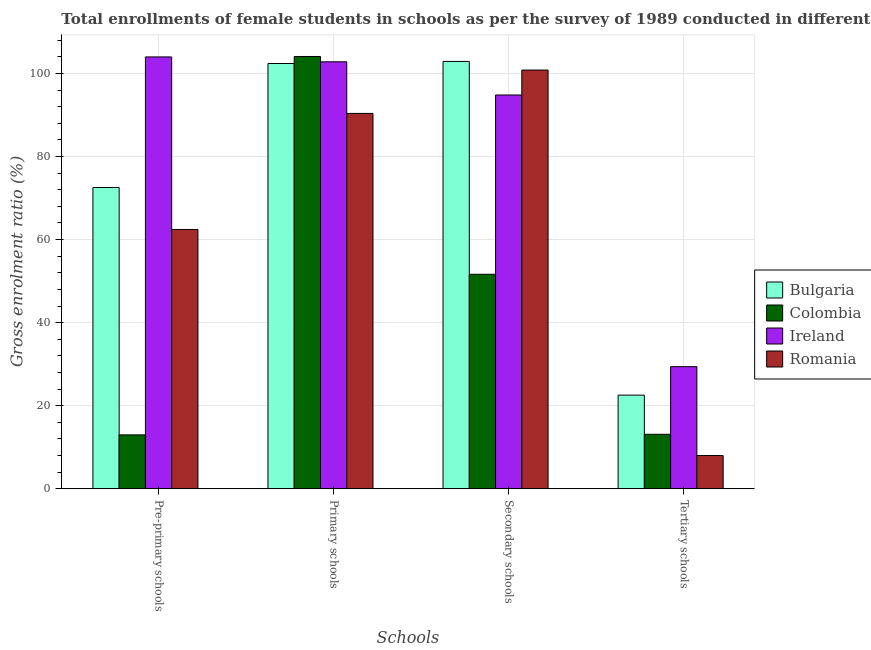How many different coloured bars are there?
Keep it short and to the point. 4. How many groups of bars are there?
Offer a very short reply. 4. Are the number of bars per tick equal to the number of legend labels?
Keep it short and to the point. Yes. Are the number of bars on each tick of the X-axis equal?
Ensure brevity in your answer.  Yes. How many bars are there on the 4th tick from the right?
Give a very brief answer. 4. What is the label of the 3rd group of bars from the left?
Make the answer very short. Secondary schools. What is the gross enrolment ratio(female) in secondary schools in Bulgaria?
Your answer should be very brief. 102.91. Across all countries, what is the maximum gross enrolment ratio(female) in pre-primary schools?
Your response must be concise. 103.99. Across all countries, what is the minimum gross enrolment ratio(female) in pre-primary schools?
Make the answer very short. 12.96. In which country was the gross enrolment ratio(female) in secondary schools maximum?
Give a very brief answer. Bulgaria. In which country was the gross enrolment ratio(female) in pre-primary schools minimum?
Your answer should be compact. Colombia. What is the total gross enrolment ratio(female) in tertiary schools in the graph?
Provide a short and direct response. 73.01. What is the difference between the gross enrolment ratio(female) in secondary schools in Bulgaria and that in Ireland?
Your response must be concise. 8.08. What is the difference between the gross enrolment ratio(female) in pre-primary schools in Ireland and the gross enrolment ratio(female) in tertiary schools in Romania?
Provide a short and direct response. 96.01. What is the average gross enrolment ratio(female) in pre-primary schools per country?
Keep it short and to the point. 62.98. What is the difference between the gross enrolment ratio(female) in primary schools and gross enrolment ratio(female) in tertiary schools in Romania?
Make the answer very short. 82.4. In how many countries, is the gross enrolment ratio(female) in pre-primary schools greater than 56 %?
Give a very brief answer. 3. What is the ratio of the gross enrolment ratio(female) in primary schools in Romania to that in Ireland?
Give a very brief answer. 0.88. What is the difference between the highest and the second highest gross enrolment ratio(female) in primary schools?
Your response must be concise. 1.28. What is the difference between the highest and the lowest gross enrolment ratio(female) in primary schools?
Keep it short and to the point. 13.71. In how many countries, is the gross enrolment ratio(female) in secondary schools greater than the average gross enrolment ratio(female) in secondary schools taken over all countries?
Your answer should be very brief. 3. Is the sum of the gross enrolment ratio(female) in primary schools in Ireland and Bulgaria greater than the maximum gross enrolment ratio(female) in pre-primary schools across all countries?
Your response must be concise. Yes. Is it the case that in every country, the sum of the gross enrolment ratio(female) in tertiary schools and gross enrolment ratio(female) in pre-primary schools is greater than the sum of gross enrolment ratio(female) in secondary schools and gross enrolment ratio(female) in primary schools?
Provide a short and direct response. No. What does the 4th bar from the left in Primary schools represents?
Provide a succinct answer. Romania. What does the 4th bar from the right in Secondary schools represents?
Ensure brevity in your answer.  Bulgaria. Is it the case that in every country, the sum of the gross enrolment ratio(female) in pre-primary schools and gross enrolment ratio(female) in primary schools is greater than the gross enrolment ratio(female) in secondary schools?
Provide a succinct answer. Yes. How many bars are there?
Offer a very short reply. 16. Are all the bars in the graph horizontal?
Provide a short and direct response. No. How many countries are there in the graph?
Your response must be concise. 4. How are the legend labels stacked?
Offer a terse response. Vertical. What is the title of the graph?
Your answer should be compact. Total enrollments of female students in schools as per the survey of 1989 conducted in different countries. Does "Mali" appear as one of the legend labels in the graph?
Your answer should be very brief. No. What is the label or title of the X-axis?
Keep it short and to the point. Schools. What is the label or title of the Y-axis?
Offer a very short reply. Gross enrolment ratio (%). What is the Gross enrolment ratio (%) of Bulgaria in Pre-primary schools?
Offer a very short reply. 72.54. What is the Gross enrolment ratio (%) in Colombia in Pre-primary schools?
Your answer should be compact. 12.96. What is the Gross enrolment ratio (%) in Ireland in Pre-primary schools?
Your response must be concise. 103.99. What is the Gross enrolment ratio (%) in Romania in Pre-primary schools?
Keep it short and to the point. 62.43. What is the Gross enrolment ratio (%) of Bulgaria in Primary schools?
Offer a terse response. 102.41. What is the Gross enrolment ratio (%) in Colombia in Primary schools?
Offer a very short reply. 104.1. What is the Gross enrolment ratio (%) in Ireland in Primary schools?
Keep it short and to the point. 102.82. What is the Gross enrolment ratio (%) of Romania in Primary schools?
Provide a short and direct response. 90.39. What is the Gross enrolment ratio (%) in Bulgaria in Secondary schools?
Your response must be concise. 102.91. What is the Gross enrolment ratio (%) of Colombia in Secondary schools?
Ensure brevity in your answer.  51.64. What is the Gross enrolment ratio (%) of Ireland in Secondary schools?
Your answer should be compact. 94.83. What is the Gross enrolment ratio (%) of Romania in Secondary schools?
Ensure brevity in your answer.  100.83. What is the Gross enrolment ratio (%) of Bulgaria in Tertiary schools?
Ensure brevity in your answer.  22.53. What is the Gross enrolment ratio (%) in Colombia in Tertiary schools?
Provide a succinct answer. 13.1. What is the Gross enrolment ratio (%) of Ireland in Tertiary schools?
Offer a terse response. 29.39. What is the Gross enrolment ratio (%) in Romania in Tertiary schools?
Provide a succinct answer. 7.99. Across all Schools, what is the maximum Gross enrolment ratio (%) in Bulgaria?
Make the answer very short. 102.91. Across all Schools, what is the maximum Gross enrolment ratio (%) in Colombia?
Provide a short and direct response. 104.1. Across all Schools, what is the maximum Gross enrolment ratio (%) of Ireland?
Your answer should be very brief. 103.99. Across all Schools, what is the maximum Gross enrolment ratio (%) in Romania?
Your response must be concise. 100.83. Across all Schools, what is the minimum Gross enrolment ratio (%) of Bulgaria?
Make the answer very short. 22.53. Across all Schools, what is the minimum Gross enrolment ratio (%) in Colombia?
Your response must be concise. 12.96. Across all Schools, what is the minimum Gross enrolment ratio (%) of Ireland?
Give a very brief answer. 29.39. Across all Schools, what is the minimum Gross enrolment ratio (%) of Romania?
Make the answer very short. 7.99. What is the total Gross enrolment ratio (%) of Bulgaria in the graph?
Your response must be concise. 300.39. What is the total Gross enrolment ratio (%) of Colombia in the graph?
Keep it short and to the point. 181.8. What is the total Gross enrolment ratio (%) of Ireland in the graph?
Make the answer very short. 331.03. What is the total Gross enrolment ratio (%) of Romania in the graph?
Your answer should be very brief. 261.64. What is the difference between the Gross enrolment ratio (%) of Bulgaria in Pre-primary schools and that in Primary schools?
Provide a short and direct response. -29.87. What is the difference between the Gross enrolment ratio (%) in Colombia in Pre-primary schools and that in Primary schools?
Your answer should be compact. -91.14. What is the difference between the Gross enrolment ratio (%) of Ireland in Pre-primary schools and that in Primary schools?
Your answer should be compact. 1.18. What is the difference between the Gross enrolment ratio (%) in Romania in Pre-primary schools and that in Primary schools?
Provide a succinct answer. -27.96. What is the difference between the Gross enrolment ratio (%) of Bulgaria in Pre-primary schools and that in Secondary schools?
Provide a short and direct response. -30.37. What is the difference between the Gross enrolment ratio (%) of Colombia in Pre-primary schools and that in Secondary schools?
Offer a very short reply. -38.68. What is the difference between the Gross enrolment ratio (%) of Ireland in Pre-primary schools and that in Secondary schools?
Provide a short and direct response. 9.16. What is the difference between the Gross enrolment ratio (%) of Romania in Pre-primary schools and that in Secondary schools?
Provide a short and direct response. -38.4. What is the difference between the Gross enrolment ratio (%) in Bulgaria in Pre-primary schools and that in Tertiary schools?
Your answer should be compact. 50.01. What is the difference between the Gross enrolment ratio (%) of Colombia in Pre-primary schools and that in Tertiary schools?
Offer a very short reply. -0.14. What is the difference between the Gross enrolment ratio (%) in Ireland in Pre-primary schools and that in Tertiary schools?
Your response must be concise. 74.61. What is the difference between the Gross enrolment ratio (%) of Romania in Pre-primary schools and that in Tertiary schools?
Make the answer very short. 54.45. What is the difference between the Gross enrolment ratio (%) of Bulgaria in Primary schools and that in Secondary schools?
Your answer should be compact. -0.5. What is the difference between the Gross enrolment ratio (%) in Colombia in Primary schools and that in Secondary schools?
Make the answer very short. 52.46. What is the difference between the Gross enrolment ratio (%) in Ireland in Primary schools and that in Secondary schools?
Provide a short and direct response. 7.99. What is the difference between the Gross enrolment ratio (%) of Romania in Primary schools and that in Secondary schools?
Keep it short and to the point. -10.44. What is the difference between the Gross enrolment ratio (%) of Bulgaria in Primary schools and that in Tertiary schools?
Give a very brief answer. 79.88. What is the difference between the Gross enrolment ratio (%) in Colombia in Primary schools and that in Tertiary schools?
Your response must be concise. 91. What is the difference between the Gross enrolment ratio (%) of Ireland in Primary schools and that in Tertiary schools?
Your answer should be very brief. 73.43. What is the difference between the Gross enrolment ratio (%) of Romania in Primary schools and that in Tertiary schools?
Your answer should be compact. 82.4. What is the difference between the Gross enrolment ratio (%) of Bulgaria in Secondary schools and that in Tertiary schools?
Provide a succinct answer. 80.38. What is the difference between the Gross enrolment ratio (%) in Colombia in Secondary schools and that in Tertiary schools?
Give a very brief answer. 38.54. What is the difference between the Gross enrolment ratio (%) in Ireland in Secondary schools and that in Tertiary schools?
Offer a terse response. 65.44. What is the difference between the Gross enrolment ratio (%) in Romania in Secondary schools and that in Tertiary schools?
Offer a very short reply. 92.85. What is the difference between the Gross enrolment ratio (%) in Bulgaria in Pre-primary schools and the Gross enrolment ratio (%) in Colombia in Primary schools?
Offer a very short reply. -31.56. What is the difference between the Gross enrolment ratio (%) of Bulgaria in Pre-primary schools and the Gross enrolment ratio (%) of Ireland in Primary schools?
Provide a succinct answer. -30.28. What is the difference between the Gross enrolment ratio (%) of Bulgaria in Pre-primary schools and the Gross enrolment ratio (%) of Romania in Primary schools?
Make the answer very short. -17.85. What is the difference between the Gross enrolment ratio (%) in Colombia in Pre-primary schools and the Gross enrolment ratio (%) in Ireland in Primary schools?
Your response must be concise. -89.86. What is the difference between the Gross enrolment ratio (%) in Colombia in Pre-primary schools and the Gross enrolment ratio (%) in Romania in Primary schools?
Your response must be concise. -77.43. What is the difference between the Gross enrolment ratio (%) of Ireland in Pre-primary schools and the Gross enrolment ratio (%) of Romania in Primary schools?
Your answer should be compact. 13.6. What is the difference between the Gross enrolment ratio (%) in Bulgaria in Pre-primary schools and the Gross enrolment ratio (%) in Colombia in Secondary schools?
Ensure brevity in your answer.  20.9. What is the difference between the Gross enrolment ratio (%) of Bulgaria in Pre-primary schools and the Gross enrolment ratio (%) of Ireland in Secondary schools?
Provide a succinct answer. -22.29. What is the difference between the Gross enrolment ratio (%) of Bulgaria in Pre-primary schools and the Gross enrolment ratio (%) of Romania in Secondary schools?
Your answer should be very brief. -28.3. What is the difference between the Gross enrolment ratio (%) of Colombia in Pre-primary schools and the Gross enrolment ratio (%) of Ireland in Secondary schools?
Ensure brevity in your answer.  -81.87. What is the difference between the Gross enrolment ratio (%) of Colombia in Pre-primary schools and the Gross enrolment ratio (%) of Romania in Secondary schools?
Offer a very short reply. -87.88. What is the difference between the Gross enrolment ratio (%) in Ireland in Pre-primary schools and the Gross enrolment ratio (%) in Romania in Secondary schools?
Provide a short and direct response. 3.16. What is the difference between the Gross enrolment ratio (%) in Bulgaria in Pre-primary schools and the Gross enrolment ratio (%) in Colombia in Tertiary schools?
Your response must be concise. 59.44. What is the difference between the Gross enrolment ratio (%) in Bulgaria in Pre-primary schools and the Gross enrolment ratio (%) in Ireland in Tertiary schools?
Offer a very short reply. 43.15. What is the difference between the Gross enrolment ratio (%) of Bulgaria in Pre-primary schools and the Gross enrolment ratio (%) of Romania in Tertiary schools?
Provide a succinct answer. 64.55. What is the difference between the Gross enrolment ratio (%) of Colombia in Pre-primary schools and the Gross enrolment ratio (%) of Ireland in Tertiary schools?
Provide a short and direct response. -16.43. What is the difference between the Gross enrolment ratio (%) in Colombia in Pre-primary schools and the Gross enrolment ratio (%) in Romania in Tertiary schools?
Ensure brevity in your answer.  4.97. What is the difference between the Gross enrolment ratio (%) in Ireland in Pre-primary schools and the Gross enrolment ratio (%) in Romania in Tertiary schools?
Make the answer very short. 96.01. What is the difference between the Gross enrolment ratio (%) of Bulgaria in Primary schools and the Gross enrolment ratio (%) of Colombia in Secondary schools?
Give a very brief answer. 50.77. What is the difference between the Gross enrolment ratio (%) of Bulgaria in Primary schools and the Gross enrolment ratio (%) of Ireland in Secondary schools?
Offer a very short reply. 7.58. What is the difference between the Gross enrolment ratio (%) in Bulgaria in Primary schools and the Gross enrolment ratio (%) in Romania in Secondary schools?
Keep it short and to the point. 1.57. What is the difference between the Gross enrolment ratio (%) in Colombia in Primary schools and the Gross enrolment ratio (%) in Ireland in Secondary schools?
Offer a very short reply. 9.27. What is the difference between the Gross enrolment ratio (%) in Colombia in Primary schools and the Gross enrolment ratio (%) in Romania in Secondary schools?
Your answer should be very brief. 3.27. What is the difference between the Gross enrolment ratio (%) of Ireland in Primary schools and the Gross enrolment ratio (%) of Romania in Secondary schools?
Keep it short and to the point. 1.98. What is the difference between the Gross enrolment ratio (%) in Bulgaria in Primary schools and the Gross enrolment ratio (%) in Colombia in Tertiary schools?
Offer a very short reply. 89.31. What is the difference between the Gross enrolment ratio (%) of Bulgaria in Primary schools and the Gross enrolment ratio (%) of Ireland in Tertiary schools?
Keep it short and to the point. 73.02. What is the difference between the Gross enrolment ratio (%) in Bulgaria in Primary schools and the Gross enrolment ratio (%) in Romania in Tertiary schools?
Your answer should be compact. 94.42. What is the difference between the Gross enrolment ratio (%) of Colombia in Primary schools and the Gross enrolment ratio (%) of Ireland in Tertiary schools?
Offer a very short reply. 74.71. What is the difference between the Gross enrolment ratio (%) of Colombia in Primary schools and the Gross enrolment ratio (%) of Romania in Tertiary schools?
Your answer should be compact. 96.11. What is the difference between the Gross enrolment ratio (%) of Ireland in Primary schools and the Gross enrolment ratio (%) of Romania in Tertiary schools?
Offer a very short reply. 94.83. What is the difference between the Gross enrolment ratio (%) in Bulgaria in Secondary schools and the Gross enrolment ratio (%) in Colombia in Tertiary schools?
Give a very brief answer. 89.81. What is the difference between the Gross enrolment ratio (%) in Bulgaria in Secondary schools and the Gross enrolment ratio (%) in Ireland in Tertiary schools?
Provide a short and direct response. 73.52. What is the difference between the Gross enrolment ratio (%) of Bulgaria in Secondary schools and the Gross enrolment ratio (%) of Romania in Tertiary schools?
Provide a short and direct response. 94.92. What is the difference between the Gross enrolment ratio (%) in Colombia in Secondary schools and the Gross enrolment ratio (%) in Ireland in Tertiary schools?
Provide a succinct answer. 22.25. What is the difference between the Gross enrolment ratio (%) in Colombia in Secondary schools and the Gross enrolment ratio (%) in Romania in Tertiary schools?
Keep it short and to the point. 43.65. What is the difference between the Gross enrolment ratio (%) of Ireland in Secondary schools and the Gross enrolment ratio (%) of Romania in Tertiary schools?
Ensure brevity in your answer.  86.84. What is the average Gross enrolment ratio (%) in Bulgaria per Schools?
Ensure brevity in your answer.  75.1. What is the average Gross enrolment ratio (%) of Colombia per Schools?
Your answer should be compact. 45.45. What is the average Gross enrolment ratio (%) of Ireland per Schools?
Offer a very short reply. 82.76. What is the average Gross enrolment ratio (%) in Romania per Schools?
Your answer should be very brief. 65.41. What is the difference between the Gross enrolment ratio (%) of Bulgaria and Gross enrolment ratio (%) of Colombia in Pre-primary schools?
Your answer should be compact. 59.58. What is the difference between the Gross enrolment ratio (%) in Bulgaria and Gross enrolment ratio (%) in Ireland in Pre-primary schools?
Offer a terse response. -31.46. What is the difference between the Gross enrolment ratio (%) in Bulgaria and Gross enrolment ratio (%) in Romania in Pre-primary schools?
Provide a short and direct response. 10.1. What is the difference between the Gross enrolment ratio (%) of Colombia and Gross enrolment ratio (%) of Ireland in Pre-primary schools?
Make the answer very short. -91.04. What is the difference between the Gross enrolment ratio (%) of Colombia and Gross enrolment ratio (%) of Romania in Pre-primary schools?
Your answer should be very brief. -49.48. What is the difference between the Gross enrolment ratio (%) of Ireland and Gross enrolment ratio (%) of Romania in Pre-primary schools?
Provide a short and direct response. 41.56. What is the difference between the Gross enrolment ratio (%) in Bulgaria and Gross enrolment ratio (%) in Colombia in Primary schools?
Provide a succinct answer. -1.69. What is the difference between the Gross enrolment ratio (%) of Bulgaria and Gross enrolment ratio (%) of Ireland in Primary schools?
Keep it short and to the point. -0.41. What is the difference between the Gross enrolment ratio (%) of Bulgaria and Gross enrolment ratio (%) of Romania in Primary schools?
Ensure brevity in your answer.  12.02. What is the difference between the Gross enrolment ratio (%) in Colombia and Gross enrolment ratio (%) in Ireland in Primary schools?
Offer a terse response. 1.28. What is the difference between the Gross enrolment ratio (%) of Colombia and Gross enrolment ratio (%) of Romania in Primary schools?
Keep it short and to the point. 13.71. What is the difference between the Gross enrolment ratio (%) of Ireland and Gross enrolment ratio (%) of Romania in Primary schools?
Keep it short and to the point. 12.43. What is the difference between the Gross enrolment ratio (%) in Bulgaria and Gross enrolment ratio (%) in Colombia in Secondary schools?
Your response must be concise. 51.27. What is the difference between the Gross enrolment ratio (%) of Bulgaria and Gross enrolment ratio (%) of Ireland in Secondary schools?
Give a very brief answer. 8.08. What is the difference between the Gross enrolment ratio (%) of Bulgaria and Gross enrolment ratio (%) of Romania in Secondary schools?
Your response must be concise. 2.08. What is the difference between the Gross enrolment ratio (%) of Colombia and Gross enrolment ratio (%) of Ireland in Secondary schools?
Your answer should be very brief. -43.19. What is the difference between the Gross enrolment ratio (%) of Colombia and Gross enrolment ratio (%) of Romania in Secondary schools?
Ensure brevity in your answer.  -49.19. What is the difference between the Gross enrolment ratio (%) of Ireland and Gross enrolment ratio (%) of Romania in Secondary schools?
Your answer should be compact. -6. What is the difference between the Gross enrolment ratio (%) of Bulgaria and Gross enrolment ratio (%) of Colombia in Tertiary schools?
Offer a terse response. 9.43. What is the difference between the Gross enrolment ratio (%) in Bulgaria and Gross enrolment ratio (%) in Ireland in Tertiary schools?
Keep it short and to the point. -6.86. What is the difference between the Gross enrolment ratio (%) in Bulgaria and Gross enrolment ratio (%) in Romania in Tertiary schools?
Keep it short and to the point. 14.54. What is the difference between the Gross enrolment ratio (%) of Colombia and Gross enrolment ratio (%) of Ireland in Tertiary schools?
Ensure brevity in your answer.  -16.29. What is the difference between the Gross enrolment ratio (%) in Colombia and Gross enrolment ratio (%) in Romania in Tertiary schools?
Provide a short and direct response. 5.11. What is the difference between the Gross enrolment ratio (%) in Ireland and Gross enrolment ratio (%) in Romania in Tertiary schools?
Offer a terse response. 21.4. What is the ratio of the Gross enrolment ratio (%) of Bulgaria in Pre-primary schools to that in Primary schools?
Provide a succinct answer. 0.71. What is the ratio of the Gross enrolment ratio (%) of Colombia in Pre-primary schools to that in Primary schools?
Provide a short and direct response. 0.12. What is the ratio of the Gross enrolment ratio (%) of Ireland in Pre-primary schools to that in Primary schools?
Keep it short and to the point. 1.01. What is the ratio of the Gross enrolment ratio (%) in Romania in Pre-primary schools to that in Primary schools?
Your response must be concise. 0.69. What is the ratio of the Gross enrolment ratio (%) of Bulgaria in Pre-primary schools to that in Secondary schools?
Give a very brief answer. 0.7. What is the ratio of the Gross enrolment ratio (%) in Colombia in Pre-primary schools to that in Secondary schools?
Provide a short and direct response. 0.25. What is the ratio of the Gross enrolment ratio (%) of Ireland in Pre-primary schools to that in Secondary schools?
Your response must be concise. 1.1. What is the ratio of the Gross enrolment ratio (%) of Romania in Pre-primary schools to that in Secondary schools?
Offer a terse response. 0.62. What is the ratio of the Gross enrolment ratio (%) in Bulgaria in Pre-primary schools to that in Tertiary schools?
Provide a succinct answer. 3.22. What is the ratio of the Gross enrolment ratio (%) of Ireland in Pre-primary schools to that in Tertiary schools?
Make the answer very short. 3.54. What is the ratio of the Gross enrolment ratio (%) of Romania in Pre-primary schools to that in Tertiary schools?
Your response must be concise. 7.82. What is the ratio of the Gross enrolment ratio (%) in Bulgaria in Primary schools to that in Secondary schools?
Keep it short and to the point. 1. What is the ratio of the Gross enrolment ratio (%) in Colombia in Primary schools to that in Secondary schools?
Provide a short and direct response. 2.02. What is the ratio of the Gross enrolment ratio (%) of Ireland in Primary schools to that in Secondary schools?
Give a very brief answer. 1.08. What is the ratio of the Gross enrolment ratio (%) of Romania in Primary schools to that in Secondary schools?
Make the answer very short. 0.9. What is the ratio of the Gross enrolment ratio (%) in Bulgaria in Primary schools to that in Tertiary schools?
Your answer should be compact. 4.55. What is the ratio of the Gross enrolment ratio (%) of Colombia in Primary schools to that in Tertiary schools?
Your answer should be compact. 7.95. What is the ratio of the Gross enrolment ratio (%) of Ireland in Primary schools to that in Tertiary schools?
Ensure brevity in your answer.  3.5. What is the ratio of the Gross enrolment ratio (%) of Romania in Primary schools to that in Tertiary schools?
Provide a succinct answer. 11.32. What is the ratio of the Gross enrolment ratio (%) in Bulgaria in Secondary schools to that in Tertiary schools?
Your answer should be compact. 4.57. What is the ratio of the Gross enrolment ratio (%) of Colombia in Secondary schools to that in Tertiary schools?
Provide a succinct answer. 3.94. What is the ratio of the Gross enrolment ratio (%) in Ireland in Secondary schools to that in Tertiary schools?
Your response must be concise. 3.23. What is the ratio of the Gross enrolment ratio (%) in Romania in Secondary schools to that in Tertiary schools?
Offer a very short reply. 12.63. What is the difference between the highest and the second highest Gross enrolment ratio (%) of Bulgaria?
Give a very brief answer. 0.5. What is the difference between the highest and the second highest Gross enrolment ratio (%) of Colombia?
Provide a short and direct response. 52.46. What is the difference between the highest and the second highest Gross enrolment ratio (%) in Ireland?
Your response must be concise. 1.18. What is the difference between the highest and the second highest Gross enrolment ratio (%) of Romania?
Your answer should be compact. 10.44. What is the difference between the highest and the lowest Gross enrolment ratio (%) of Bulgaria?
Give a very brief answer. 80.38. What is the difference between the highest and the lowest Gross enrolment ratio (%) of Colombia?
Offer a terse response. 91.14. What is the difference between the highest and the lowest Gross enrolment ratio (%) of Ireland?
Your response must be concise. 74.61. What is the difference between the highest and the lowest Gross enrolment ratio (%) of Romania?
Ensure brevity in your answer.  92.85. 